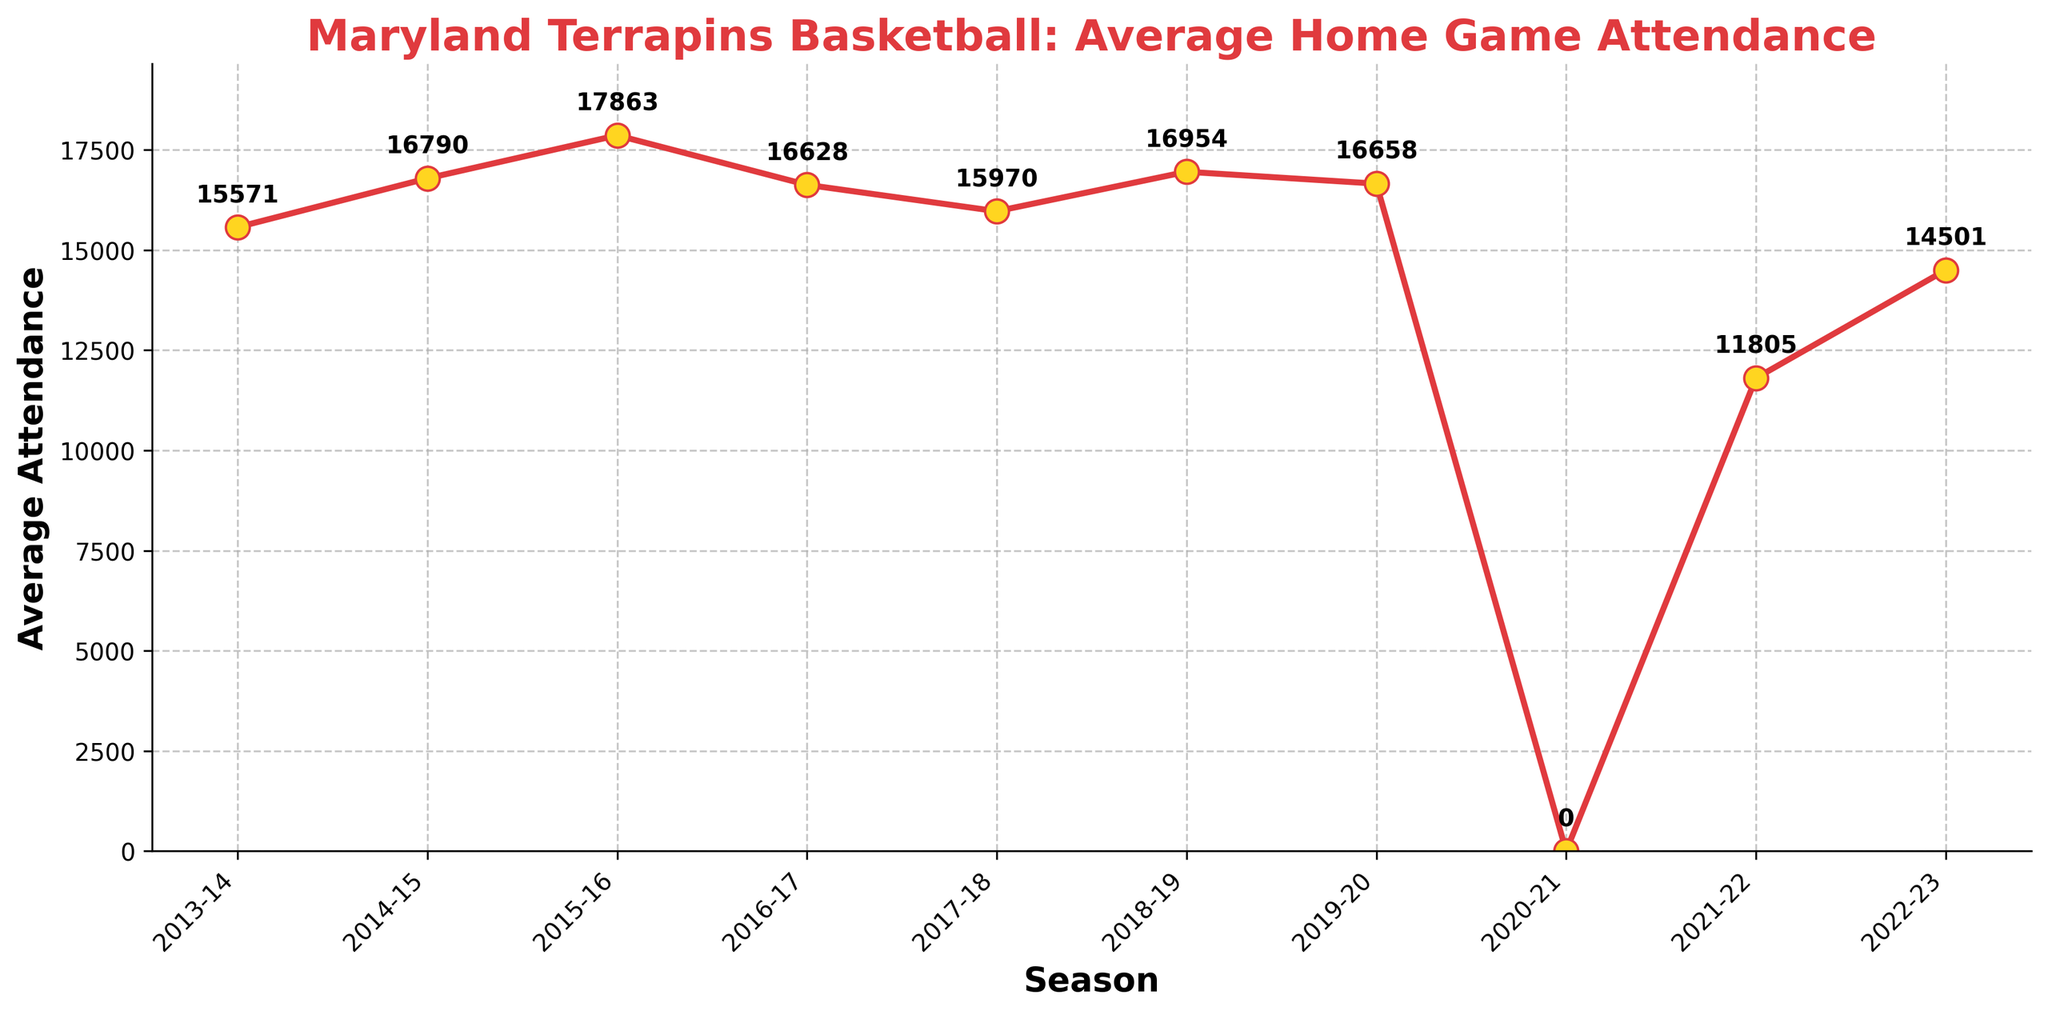what season saw the highest average attendance? First, identify the highest point on the line plot. Then, refer to the x-axis label corresponding to that point. The highest average attendance is 17863, which occurred in the 2015-16 season.
Answer: 2015-16 what is the average attendance change from 2013-14 to 2014-15? Subtract the average attendance of 2013-14 from that of 2014-15: 16790 - 15571. This gives the change.
Answer: 1219 which season experienced an average attendance drop compared to the previous season? Look for points where the line drops from one season to the next. This happens from 2015-16 to 2016-17 (17863 vs. 16628) and from 2018-19 to 2019-20 (16954 vs. 16658).
Answer: 2016-17, 2019-20 how many seasons had an attendance greater than 16,000? Count the number of seasons with an average attendance value above 16,000. These are 2013-14 (15571), 2014-15 (16790), 2015-16 (17863), 2016-17 (16628), 2017-18 (15970), and 2018-19 (16954). So, the count is 4 seasons.
Answer: 4 what was the attendance in the 2020-21 season? Why was it different? Identify the value for the 2020-21 season on the plot. It shows 0. This difference is likely due to the COVID-19 pandemic which impacted sporting events and minimized or eliminated attendance.
Answer: 0 what is the total sum of attendances from 2018-19 to 2022-23? Sum up the average attendance values for the seasons 2018-19 to 2022-23: 16954 + 16658 + 0 + 11805 + 14501 = 59818.
Answer: 59818 during which season did the average attendance first surpass 17,000? Look for the first point where the line crosses the 17,000 mark. This happens in 2015-16 with an average attendance of 17863.
Answer: 2015-16 what is the mean average attendance over the 10 seasons? Sum the average attendances and divide by the number of seasons (10). The sum is 142,440, so the mean is 142,440 / 10 = 14,244.
Answer: 14244 which season had the closest attendance to the mean value? Calculate the distance of each season’s average attendance to the mean (14244) and find the smallest distance. 2013-14 (15571-14244=1327), 2014-15 (16790-14244=2546), 2015-16 (17863-14244=3619), 2016-17 (16628-14244=2384), 2017-18 (15970-14244=1726), 2018-19 (16954-14244=2710), 2019-20 (16658-14244=2414), 2020-21 (14244-0=14244), 2021-22 (14501-14244=257), 2022-23 (14501-14244=257). Both 2021-22 and 2022-23 seasons.
Answer: 2021-22, 2022-23 